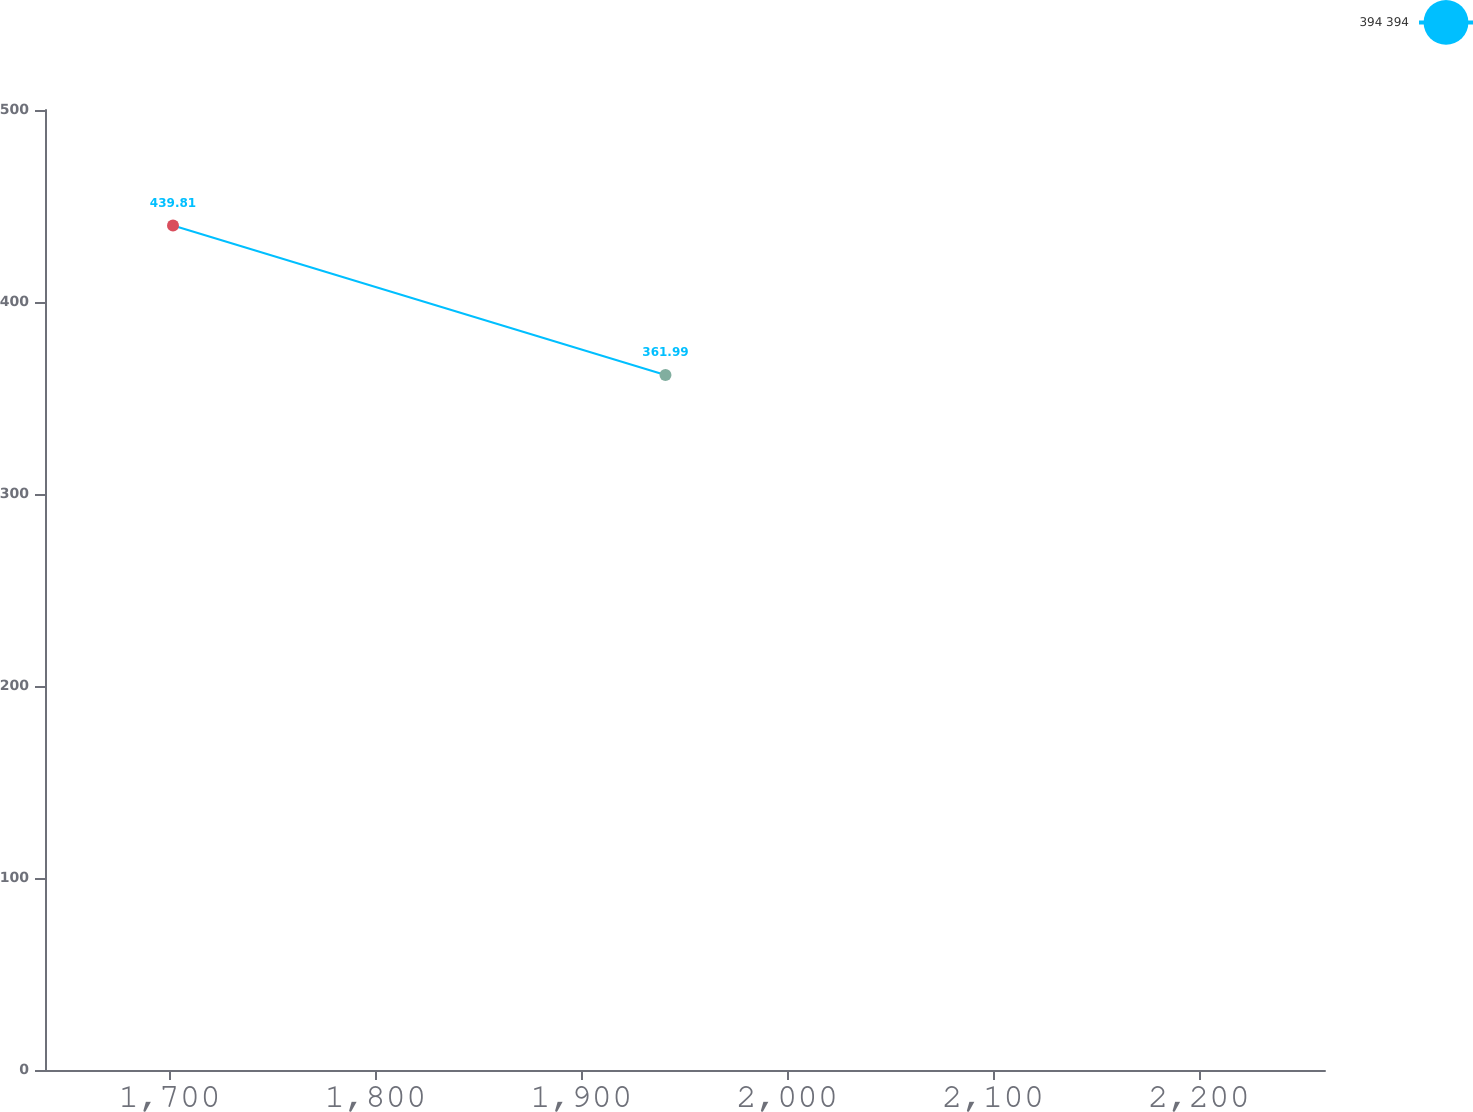Convert chart to OTSL. <chart><loc_0><loc_0><loc_500><loc_500><line_chart><ecel><fcel>394 394<nl><fcel>1701.68<fcel>439.81<nl><fcel>1940.89<fcel>361.99<nl><fcel>2323.42<fcel>347.4<nl></chart> 